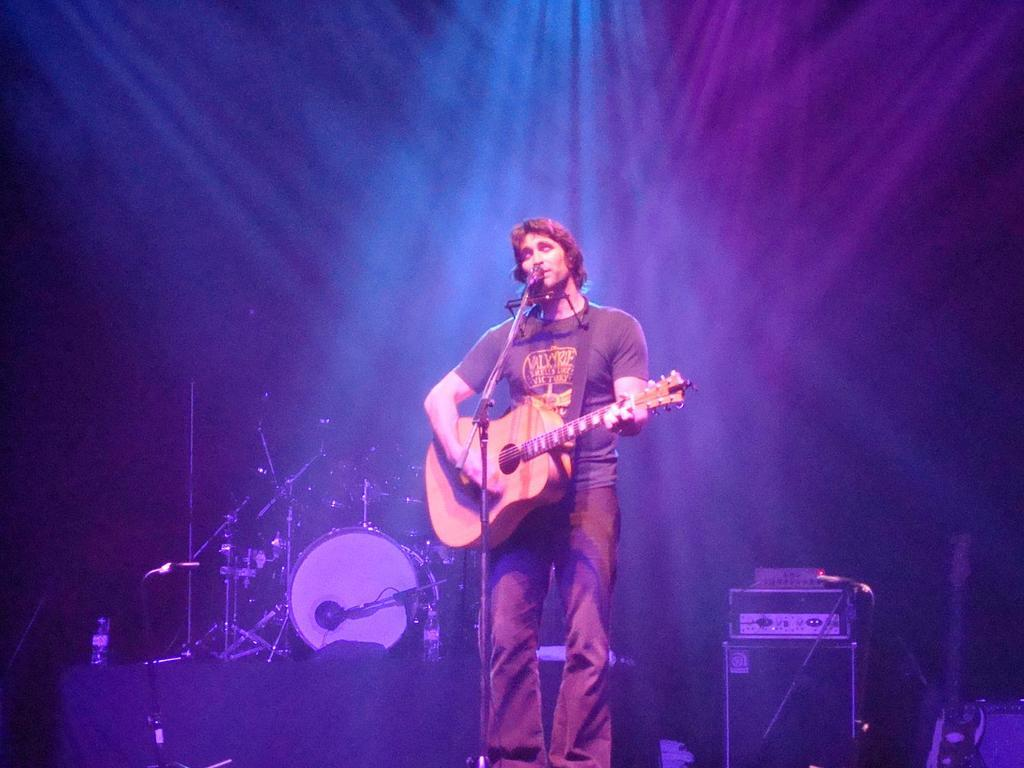What is the man in the image doing? The man is playing a guitar and singing. What object is the man using to amplify his voice? There is a microphone in the image. What device is used to amplify the sound of the musical instruments? There is a loudspeaker in the image. What can be seen on the bench besides the man? There are other musical instruments on the bench. What type of musical instrument is the man playing? There is a guitar in the image. How many snails can be seen crawling on the guitar in the image? There are no snails present in the image; it features a man playing a guitar and singing. What scientific experiment is being conducted in the image? There is no scientific experiment being conducted in the image; it shows a man playing a guitar and singing. 